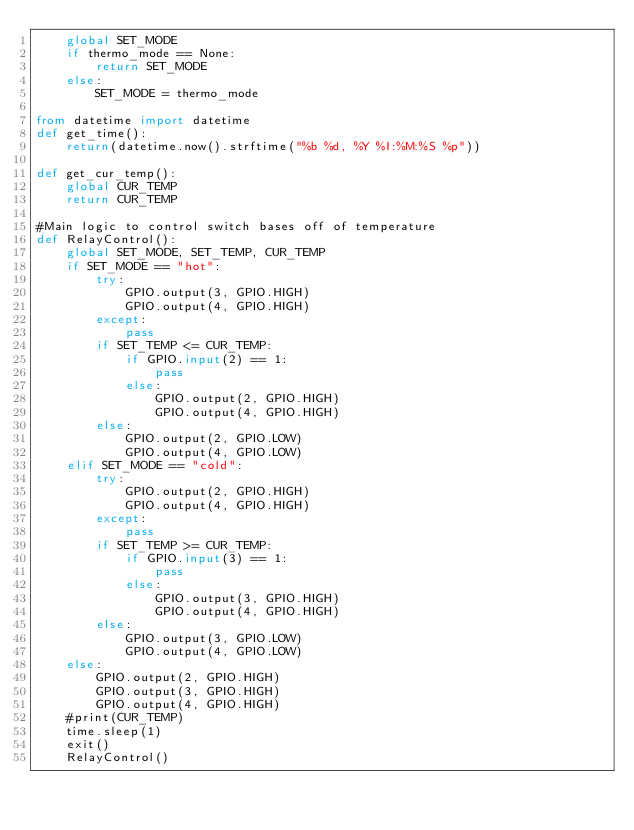Convert code to text. <code><loc_0><loc_0><loc_500><loc_500><_Python_>	global SET_MODE
	if thermo_mode == None:
		return SET_MODE
	else:
		SET_MODE = thermo_mode

from datetime import datetime
def get_time():
	return(datetime.now().strftime("%b %d, %Y %I:%M:%S %p"))

def get_cur_temp():
    global CUR_TEMP
    return CUR_TEMP

#Main logic to control switch bases off of temperature
def RelayControl():
	global SET_MODE, SET_TEMP, CUR_TEMP
	if SET_MODE == "hot":
		try:
			GPIO.output(3, GPIO.HIGH)
			GPIO.output(4, GPIO.HIGH)
		except:
			pass
		if SET_TEMP <= CUR_TEMP:
			if GPIO.input(2) == 1:
				pass
			else:
				GPIO.output(2, GPIO.HIGH)
				GPIO.output(4, GPIO.HIGH)
		else:
			GPIO.output(2, GPIO.LOW)
			GPIO.output(4, GPIO.LOW)
	elif SET_MODE == "cold":
		try:
			GPIO.output(2, GPIO.HIGH)
			GPIO.output(4, GPIO.HIGH)
		except:
			pass
		if SET_TEMP >= CUR_TEMP:
			if GPIO.input(3) == 1:
				pass
			else:
				GPIO.output(3, GPIO.HIGH)
				GPIO.output(4, GPIO.HIGH)
		else:
			GPIO.output(3, GPIO.LOW)
			GPIO.output(4, GPIO.LOW)
	else:
		GPIO.output(2, GPIO.HIGH)
		GPIO.output(3, GPIO.HIGH)
		GPIO.output(4, GPIO.HIGH)
	#print(CUR_TEMP)
	time.sleep(1)
	exit()
	RelayControl()
</code> 